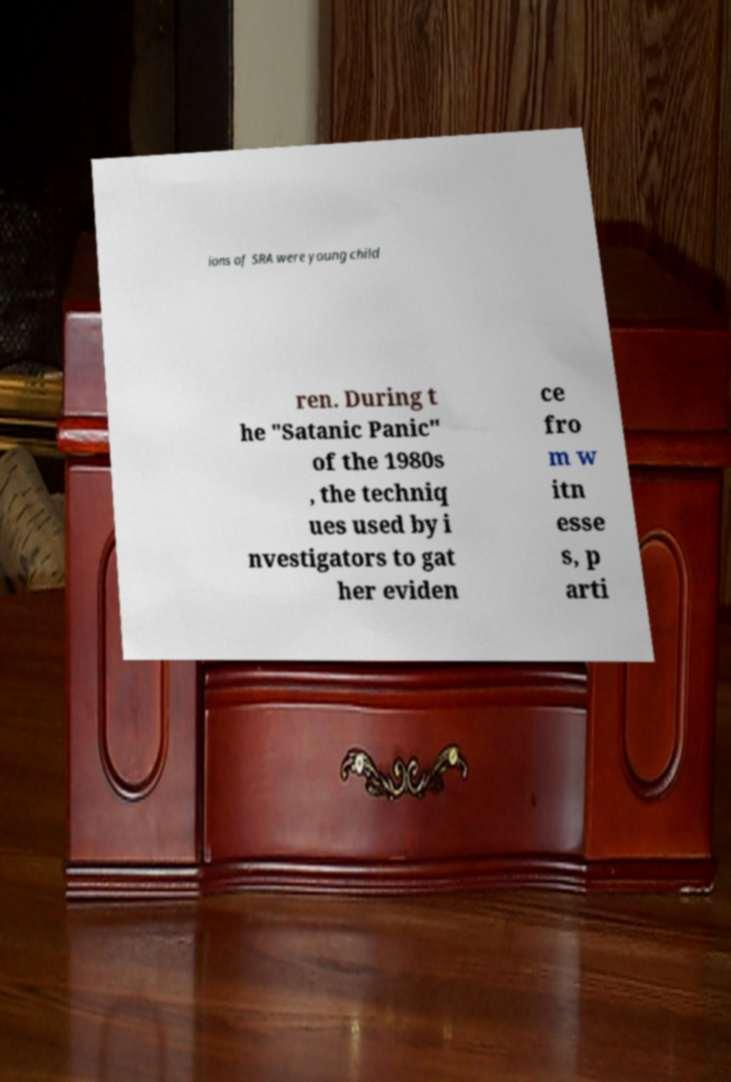For documentation purposes, I need the text within this image transcribed. Could you provide that? ions of SRA were young child ren. During t he "Satanic Panic" of the 1980s , the techniq ues used by i nvestigators to gat her eviden ce fro m w itn esse s, p arti 